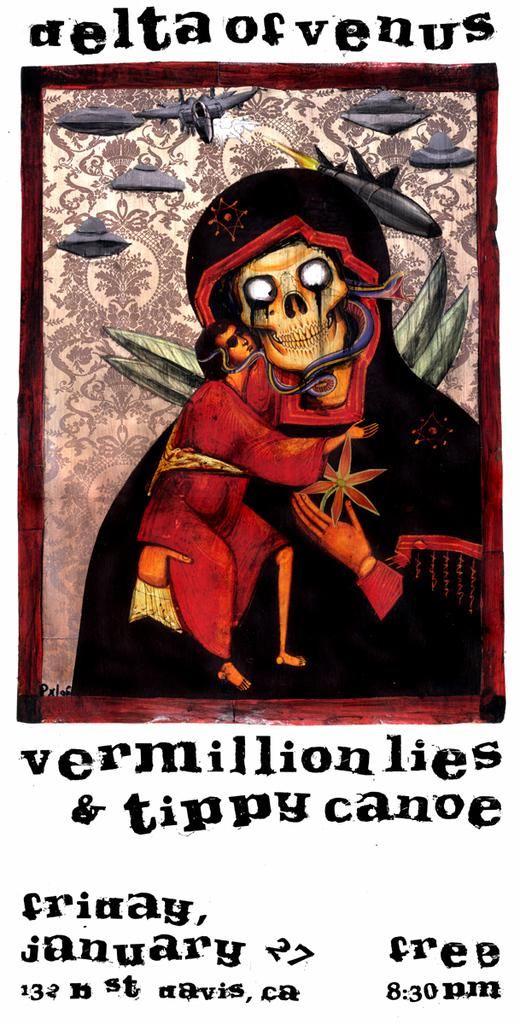<image>
Create a compact narrative representing the image presented. A poster with a skeleton in war gear gives information for a played called Vermillion Lies and Tippy Canoe 